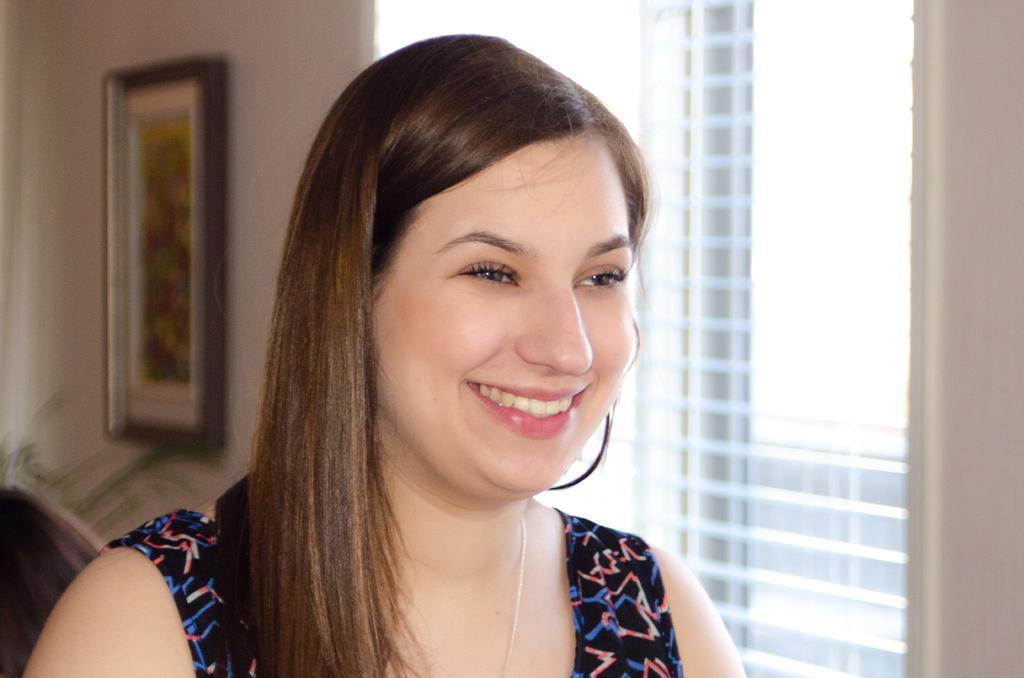Describe this image in one or two sentences. In this image I can see a person and the person is wearing black and blue color dress. Background I can see few windows and a frame attached to the wall and the wall is cream color. 